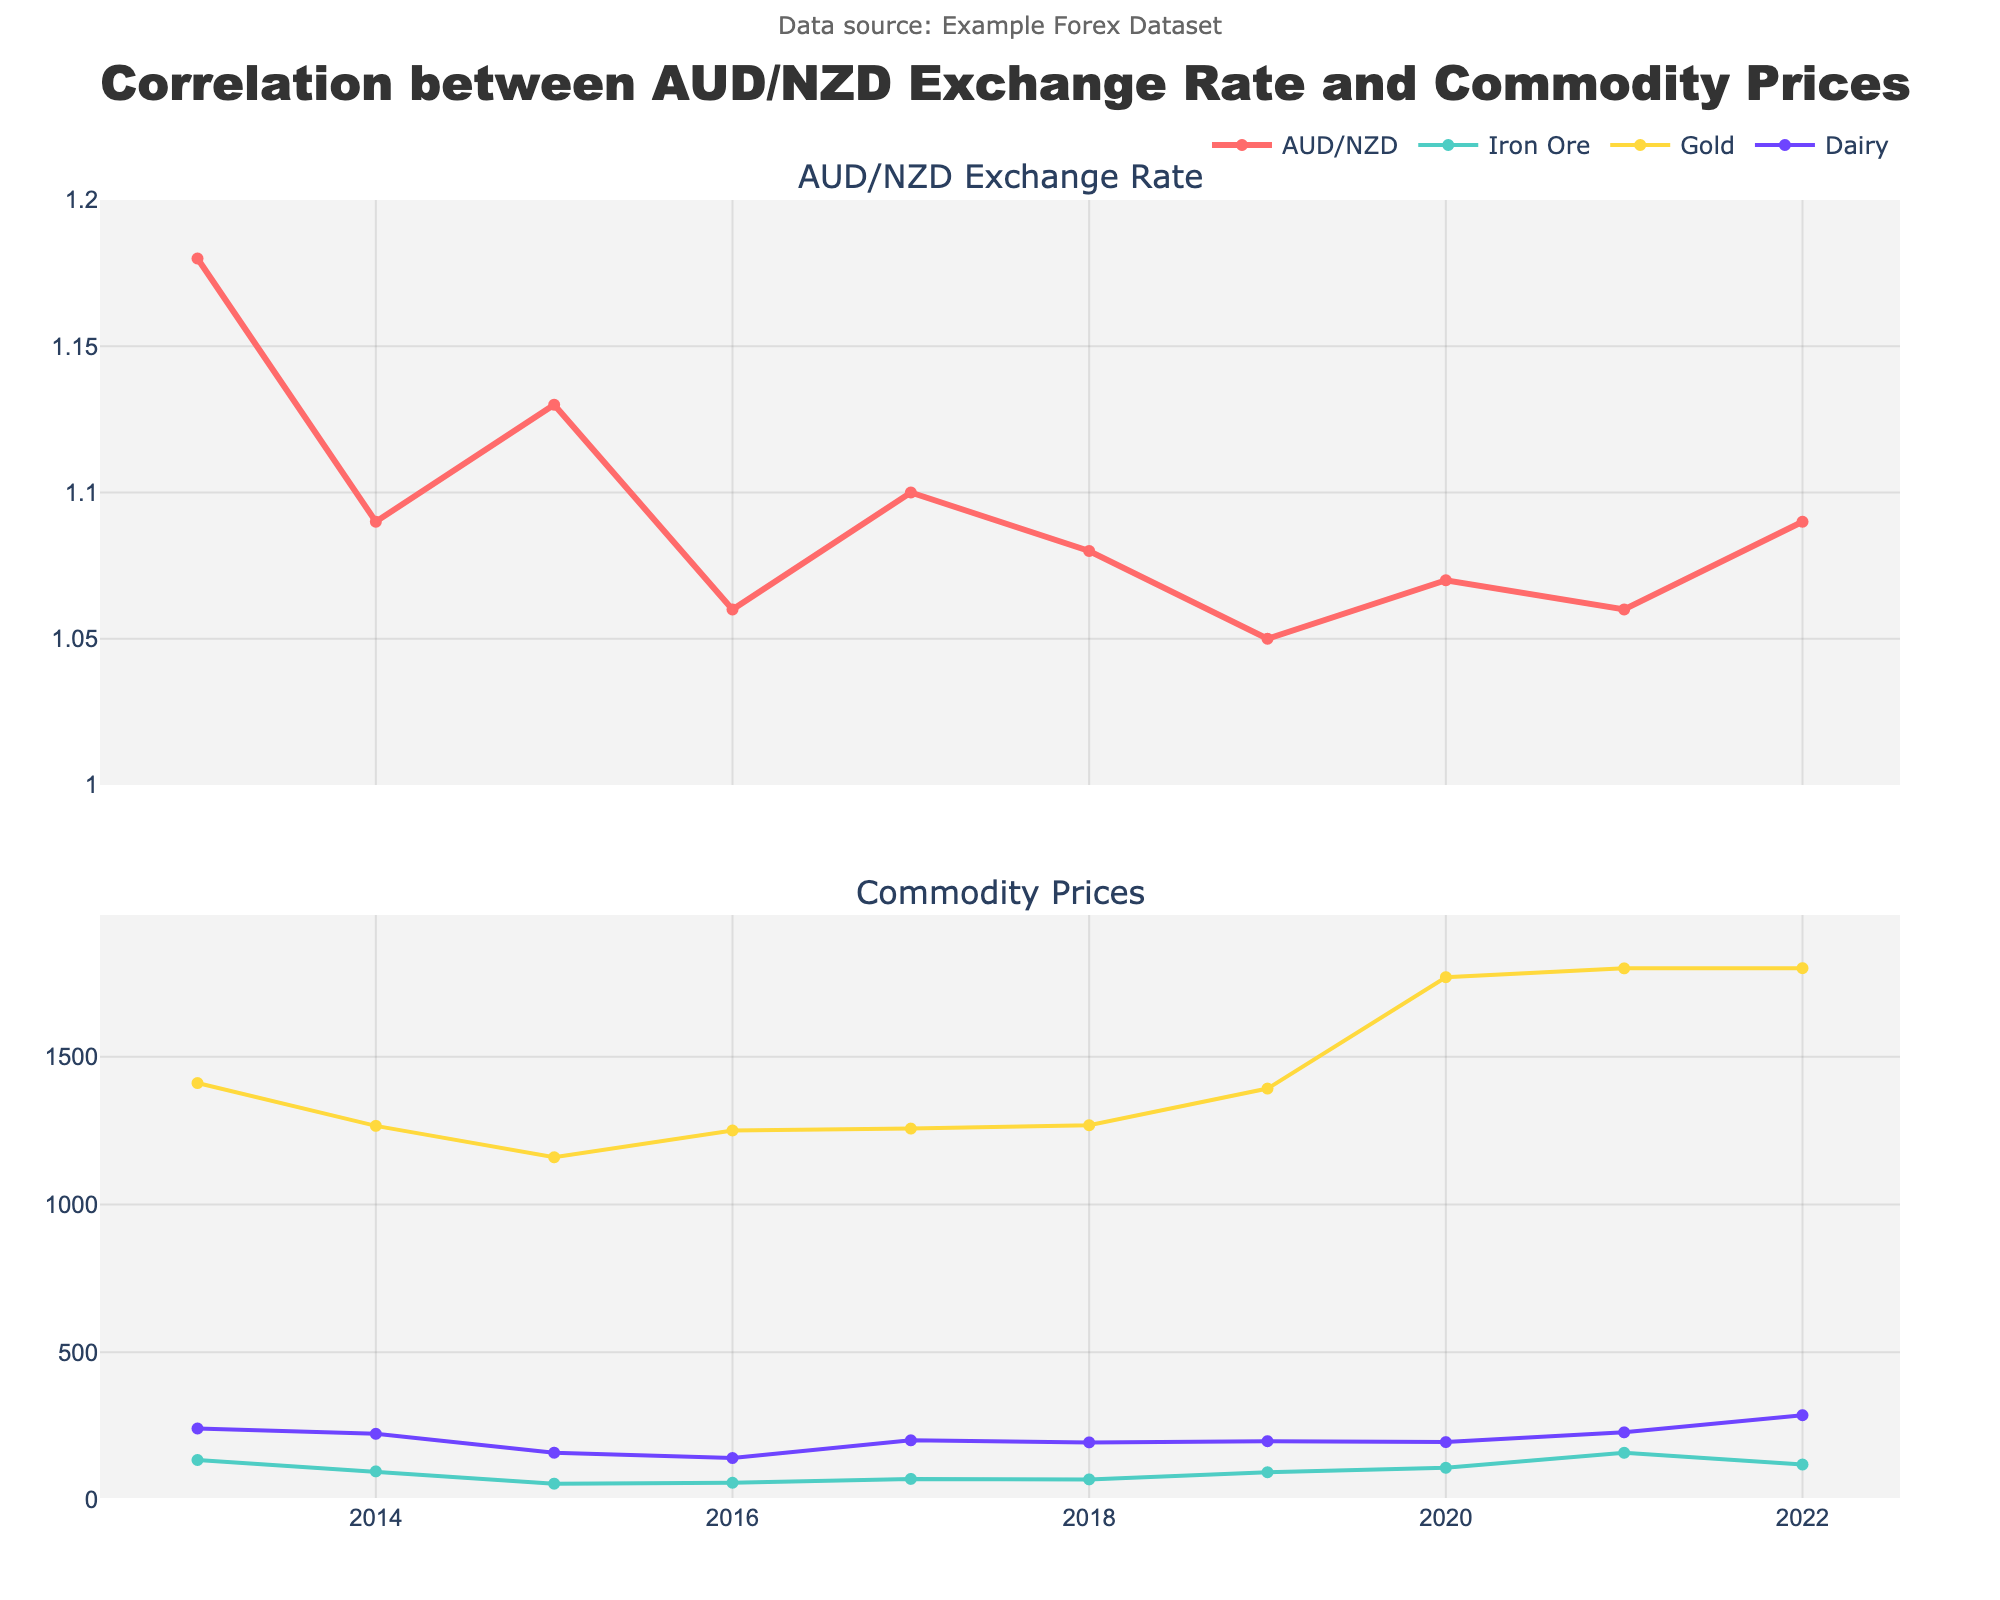What was the AUD/NZD exchange rate in 2015 and how did it compare to 2019? The AUD/NZD exchange rate in 2015 was 1.13, whereas in 2019, it was 1.05. Comparing these, the rate decreased from 1.13 in 2015 to 1.05 in 2019, showing a drop of 0.08.
Answer: 2015: 1.13, 2019: 1.05, decreased by 0.08 Between which two consecutive years did the Iron Ore Price see the largest increase? The largest increase in Iron Ore Price occurred between 2020 and 2021, where the price jumped from 108.98 USD/ton to 159.79 USD/ton, an increase of 50.81 USD/ton.
Answer: 2020 and 2021 What is the general trend of the Gold Price from 2013 to 2022 depicted in the chart? From 2013 to 2022, the Gold Price generally shows an increasing trend, starting from 1411.23 USD/oz in 2013 and increasing to approximately 1800 USD/oz by 2022. There are slight fluctuations, but the overall trajectory is upward.
Answer: Increasing trend Compare the Dairy Price Index in 2015 with the Dairy Price Index in 2022 and identify the difference. The Dairy Price Index was 160 in 2015 and 287 in 2022. The difference between the two values is 287 - 160 = 127, indicating an increase.
Answer: Increased by 127 Which commodity had the most noticeable fluctuations in its price throughout the decade? Looking at the chart, Iron Ore Price had the most noticeable fluctuations, with significant highs and lows, unlike Gold and Dairy prices which were relatively more stable.
Answer: Iron Ore What was the average Iron Ore Price over the given years? To calculate the average, sum the Iron Ore Prices and divide by the number of years: (135.36 + 96.84 + 55.21 + 58.45 + 71.32 + 69.75 + 93.85 + 108.98 + 159.79 + 120.01) / 10 = 97.956.
Answer: 97.96 USD/ton How did the AUD/NZD exchange rate change from 2020 to 2021? The AUD/NZD exchange rate slightly decreased from 1.07 in 2020 to 1.06 in 2021, indicating a marginal drop of 0.01.
Answer: Decreased by 0.01 During which year was the Dairy Price Index the lowest and what was its value? The Dairy Price Index was the lowest in 2016 with a value of 142.
Answer: 2016, 142 